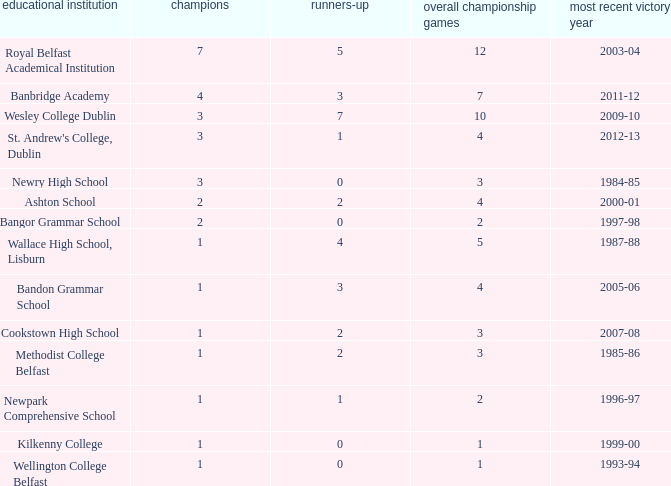How many total finals where there when the last win was in 2012-13? 4.0. 